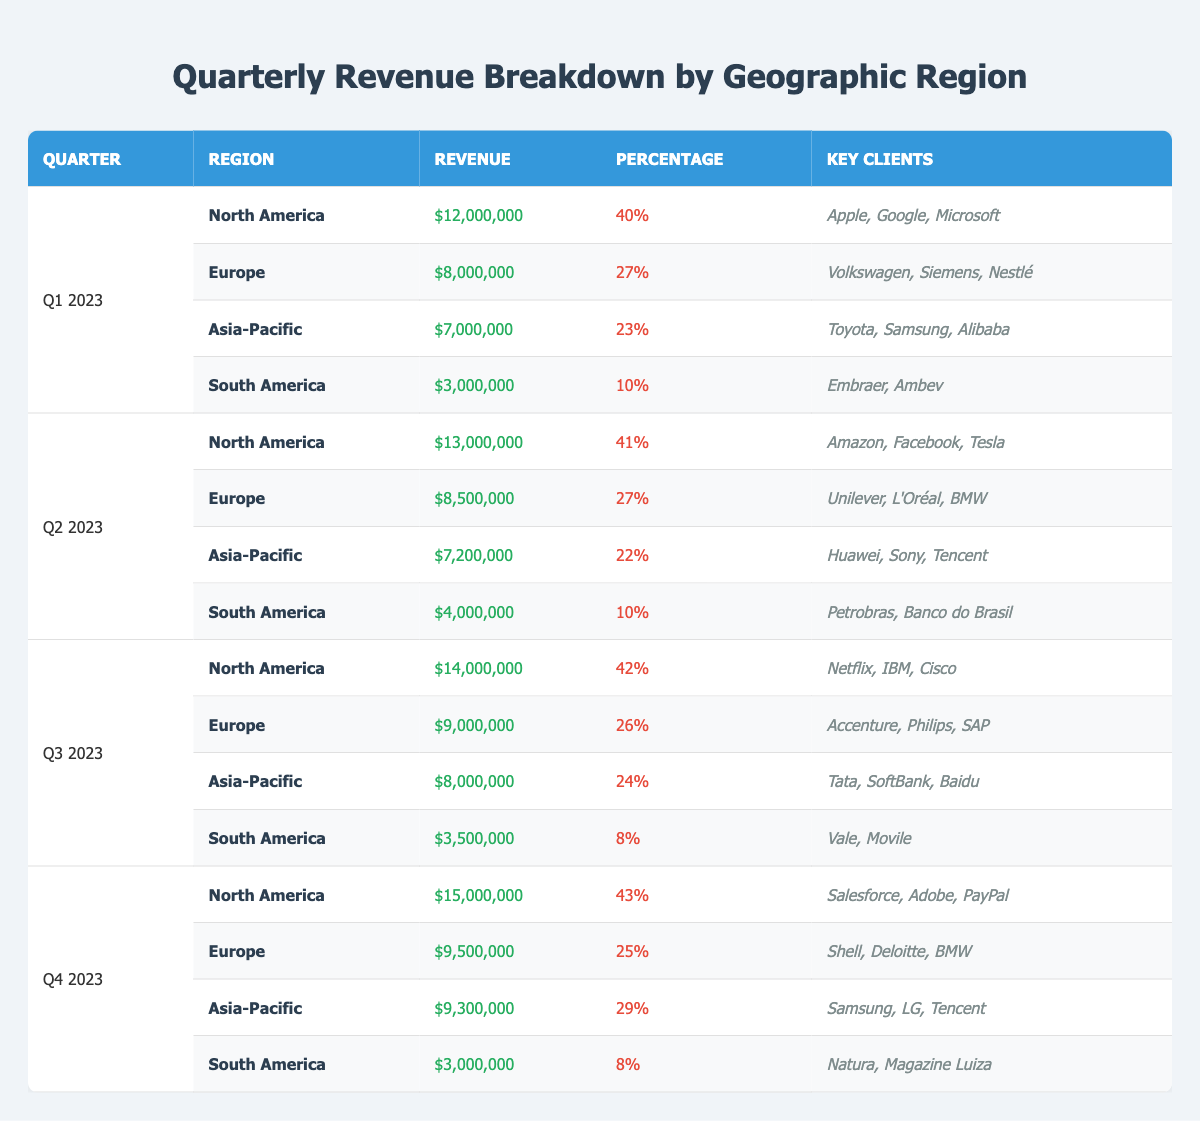What was the total revenue from North America in Q1 2023? Referring to the table, North America's revenue for Q1 2023 is $12,000,000.
Answer: $12,000,000 Which region had the highest revenue in Q4 2023? In Q4 2023, North America had a revenue of $15,000,000, which is the highest among all regions listed.
Answer: North America What is the percentage of revenue from South America in Q3 2023? For Q3 2023, South America's revenue percentage is 8%, as indicated in the table.
Answer: 8% How did the revenue from Asia-Pacific change from Q1 to Q4 2023? In Q1 2023, the revenue from Asia-Pacific was $7,000,000, and in Q4 2023, it increased to $9,300,000. The difference is $9,300,000 - $7,000,000 = $2,300,000, which shows an increase.
Answer: Increased by $2,300,000 What is the average percentage revenue for Europe over all quarters? The percentages for Europe are 27% (Q1), 27% (Q2), 26% (Q3), and 25% (Q4). Adding these gives 27 + 27 + 26 + 25 = 105, and dividing by 4 gives 105 / 4 = 26.25%.
Answer: 26.25% In which quarter did Asia-Pacific have the lowest revenue? The revenues for Asia-Pacific over the quarters are $7,000,000 (Q1), $7,200,000 (Q2), $8,000,000 (Q3), and $9,300,000 (Q4). The lowest is $7,000,000 in Q1 2023.
Answer: Q1 2023 Does Europe account for more than 30% of the total revenue in Q2 2023? In Q2 2023, Europe's percentage is 27%, which is less than 30%, so the statement is false.
Answer: No What is the total revenue from all regions in Q1 2023? The total revenue for Q1 2023 is found by adding the revenues: $12,000,000 (North America) + $8,000,000 (Europe) + $7,000,000 (Asia-Pacific) + $3,000,000 (South America) = $30,000,000.
Answer: $30,000,000 Which region consistently shows an increase in revenue across the quarters? Reviewing the revenue for North America: $12,000,000 (Q1), $13,000,000 (Q2), $14,000,000 (Q3), and $15,000,000 (Q4), we see it consistently increases.
Answer: North America How much revenue did South America generate in Q2 2023 compared to Q3 2023? In Q2 2023, South America generated $4,000,000, and in Q3 2023, it generated $3,500,000. The difference in revenue is $4,000,000 - $3,500,000 = $500,000.
Answer: Revenue decreased by $500,000 What proportion of total revenue in Q4 2023 came from Europe? In Q4 2023, total revenue is $15,000,000 (North America) + $9,500,000 (Europe) + $9,300,000 (Asia-Pacific) + $3,000,000 (South America) = $36,800,000. Europe's share is $9,500,000 / $36,800,000 ≈ 0.257 or 25.7%.
Answer: 25.7% 